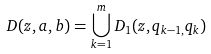<formula> <loc_0><loc_0><loc_500><loc_500>D ( z , a , b ) = \bigcup _ { k = 1 } ^ { m } D _ { 1 } ( z , q _ { k - 1 , } q _ { k } )</formula> 